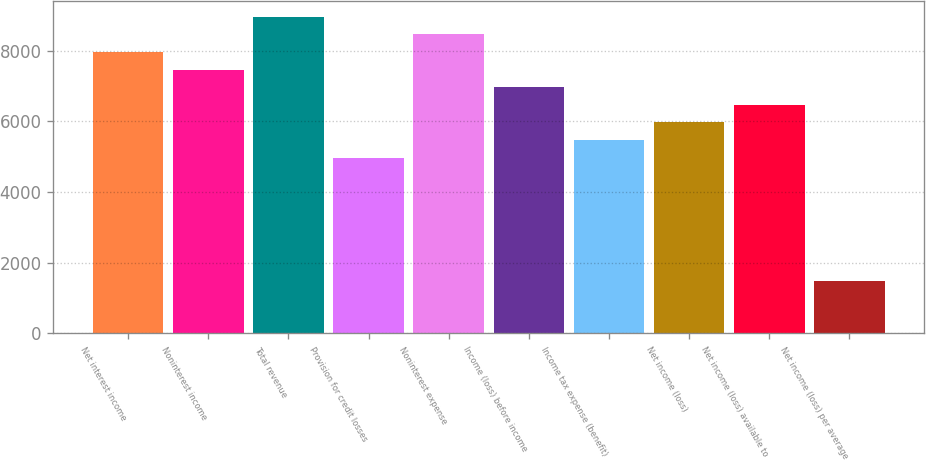<chart> <loc_0><loc_0><loc_500><loc_500><bar_chart><fcel>Net interest income<fcel>Noninterest income<fcel>Total revenue<fcel>Provision for credit losses<fcel>Noninterest expense<fcel>Income (loss) before income<fcel>Income tax expense (benefit)<fcel>Net income (loss)<fcel>Net income (loss) available to<fcel>Net income (loss) per average<nl><fcel>7965.96<fcel>7468.13<fcel>8961.62<fcel>4978.98<fcel>8463.79<fcel>6970.3<fcel>5476.81<fcel>5974.64<fcel>6472.47<fcel>1494.17<nl></chart> 